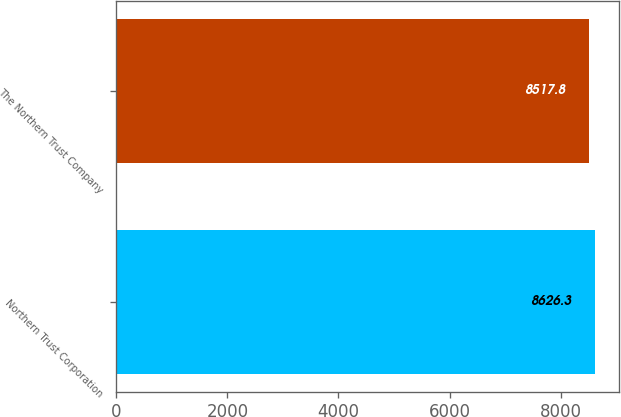Convert chart. <chart><loc_0><loc_0><loc_500><loc_500><bar_chart><fcel>Northern Trust Corporation<fcel>The Northern Trust Company<nl><fcel>8626.3<fcel>8517.8<nl></chart> 